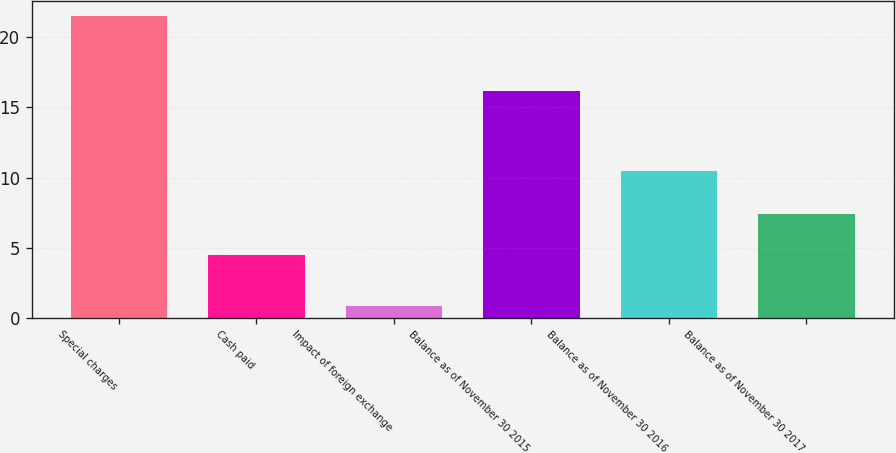Convert chart to OTSL. <chart><loc_0><loc_0><loc_500><loc_500><bar_chart><fcel>Special charges<fcel>Cash paid<fcel>Impact of foreign exchange<fcel>Balance as of November 30 2015<fcel>Balance as of November 30 2016<fcel>Balance as of November 30 2017<nl><fcel>21.5<fcel>4.5<fcel>0.8<fcel>16.2<fcel>10.5<fcel>7.4<nl></chart> 